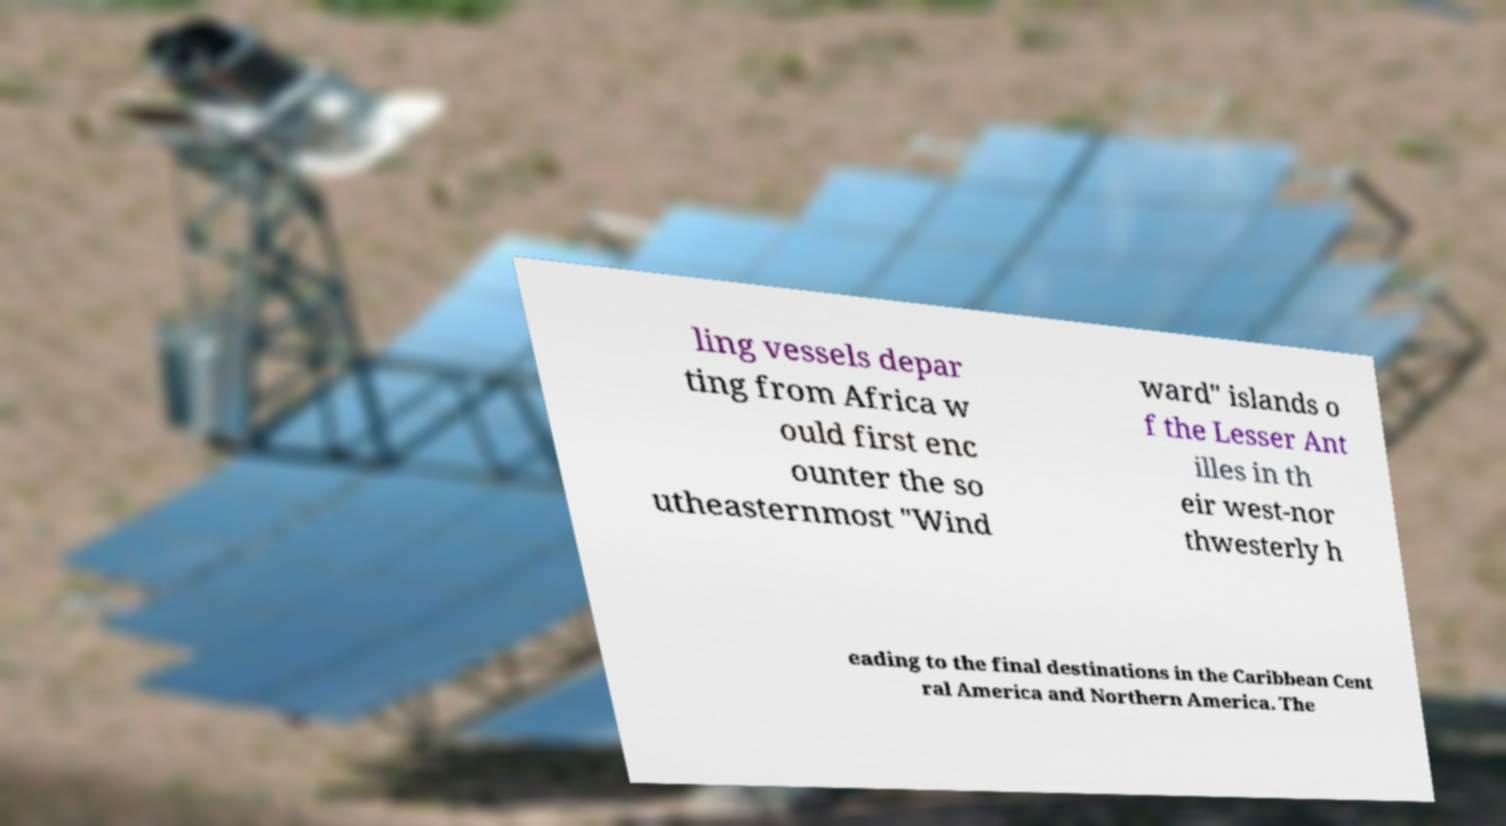Can you accurately transcribe the text from the provided image for me? ling vessels depar ting from Africa w ould first enc ounter the so utheasternmost "Wind ward" islands o f the Lesser Ant illes in th eir west-nor thwesterly h eading to the final destinations in the Caribbean Cent ral America and Northern America. The 